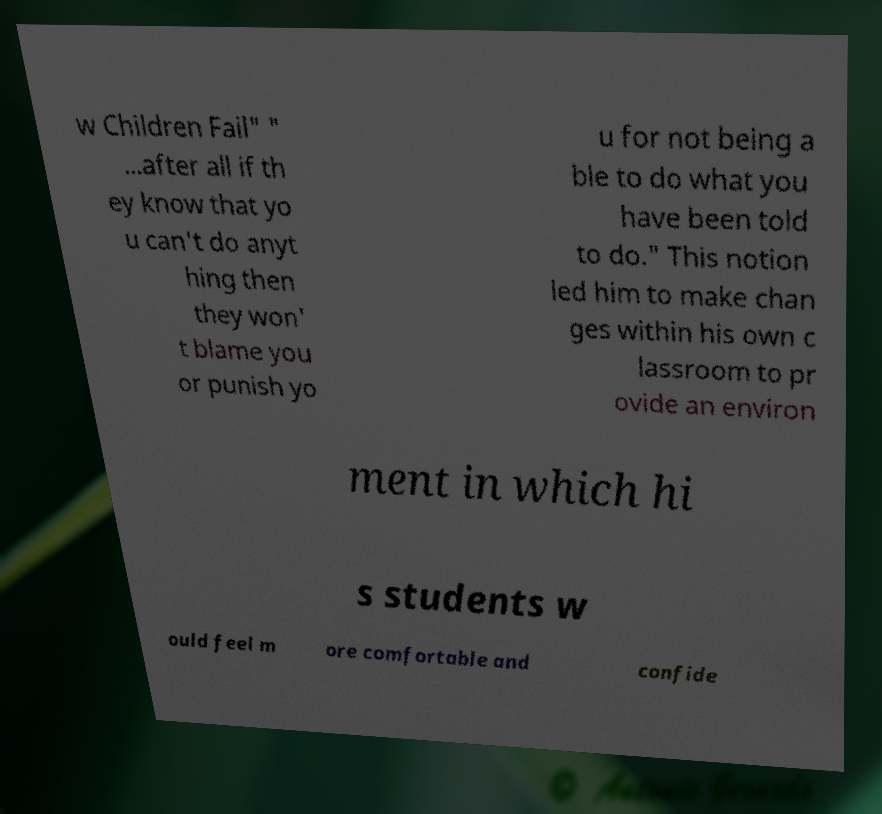What messages or text are displayed in this image? I need them in a readable, typed format. w Children Fail" " ...after all if th ey know that yo u can't do anyt hing then they won' t blame you or punish yo u for not being a ble to do what you have been told to do." This notion led him to make chan ges within his own c lassroom to pr ovide an environ ment in which hi s students w ould feel m ore comfortable and confide 